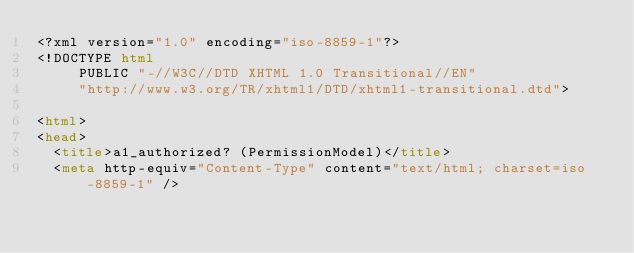Convert code to text. <code><loc_0><loc_0><loc_500><loc_500><_HTML_><?xml version="1.0" encoding="iso-8859-1"?>
<!DOCTYPE html 
     PUBLIC "-//W3C//DTD XHTML 1.0 Transitional//EN"
     "http://www.w3.org/TR/xhtml1/DTD/xhtml1-transitional.dtd">

<html>
<head>
  <title>a1_authorized? (PermissionModel)</title>
  <meta http-equiv="Content-Type" content="text/html; charset=iso-8859-1" /></code> 